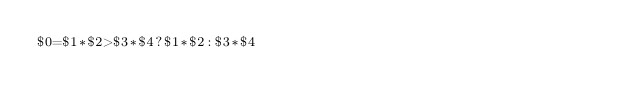Convert code to text. <code><loc_0><loc_0><loc_500><loc_500><_Awk_>$0=$1*$2>$3*$4?$1*$2:$3*$4</code> 